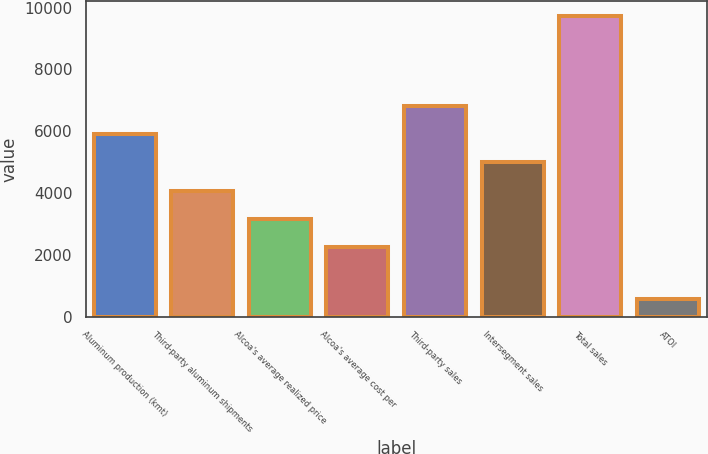Convert chart to OTSL. <chart><loc_0><loc_0><loc_500><loc_500><bar_chart><fcel>Aluminum production (kmt)<fcel>Third-party aluminum shipments<fcel>Alcoa's average realized price<fcel>Alcoa's average cost per<fcel>Third-party sales<fcel>Intersegment sales<fcel>Total sales<fcel>ATOI<nl><fcel>5906.8<fcel>4079.4<fcel>3165.7<fcel>2252<fcel>6820.5<fcel>4993.1<fcel>9731<fcel>594<nl></chart> 